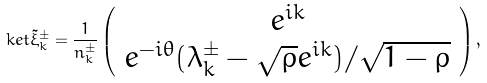Convert formula to latex. <formula><loc_0><loc_0><loc_500><loc_500>\ k e t { \tilde { \xi } _ { k } ^ { \pm } } = \frac { 1 } { n _ { k } ^ { \pm } } \left ( \begin{array} { c } e ^ { i k } \\ e ^ { - i \theta } ( \lambda _ { k } ^ { \pm } - \sqrt { \rho } e ^ { i k } ) / \sqrt { 1 - \rho } \\ \end{array} \right ) ,</formula> 